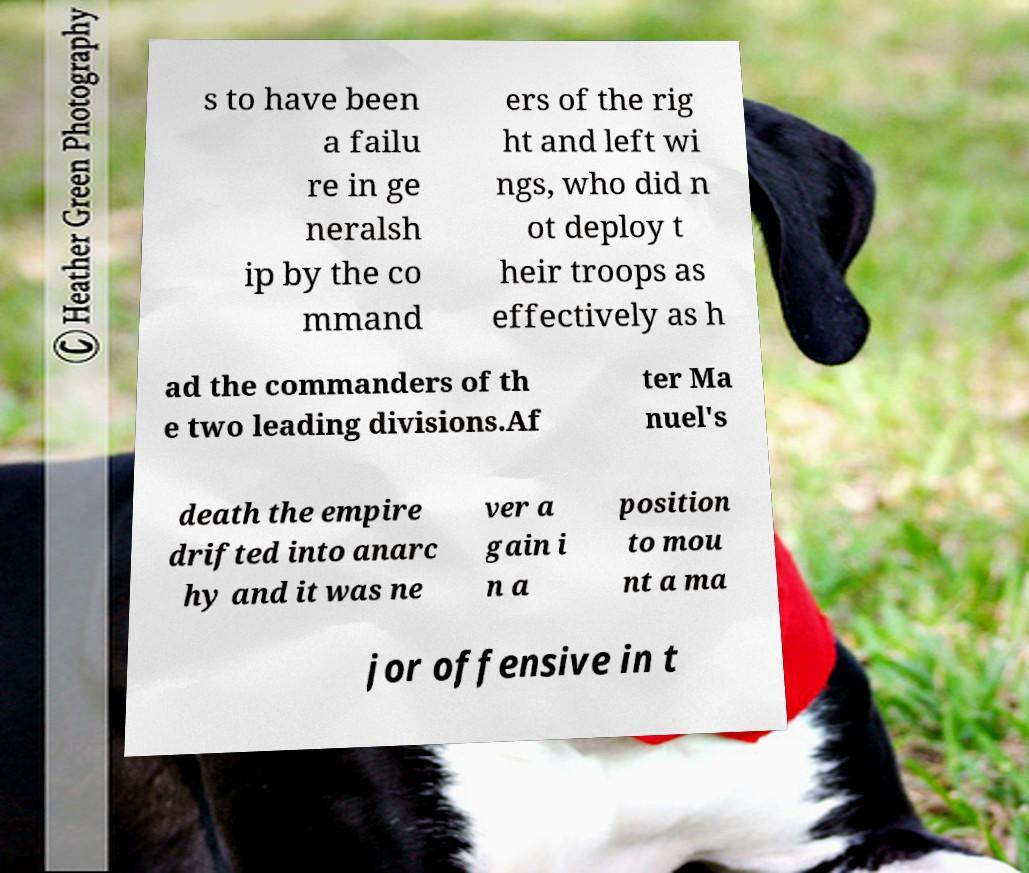There's text embedded in this image that I need extracted. Can you transcribe it verbatim? s to have been a failu re in ge neralsh ip by the co mmand ers of the rig ht and left wi ngs, who did n ot deploy t heir troops as effectively as h ad the commanders of th e two leading divisions.Af ter Ma nuel's death the empire drifted into anarc hy and it was ne ver a gain i n a position to mou nt a ma jor offensive in t 